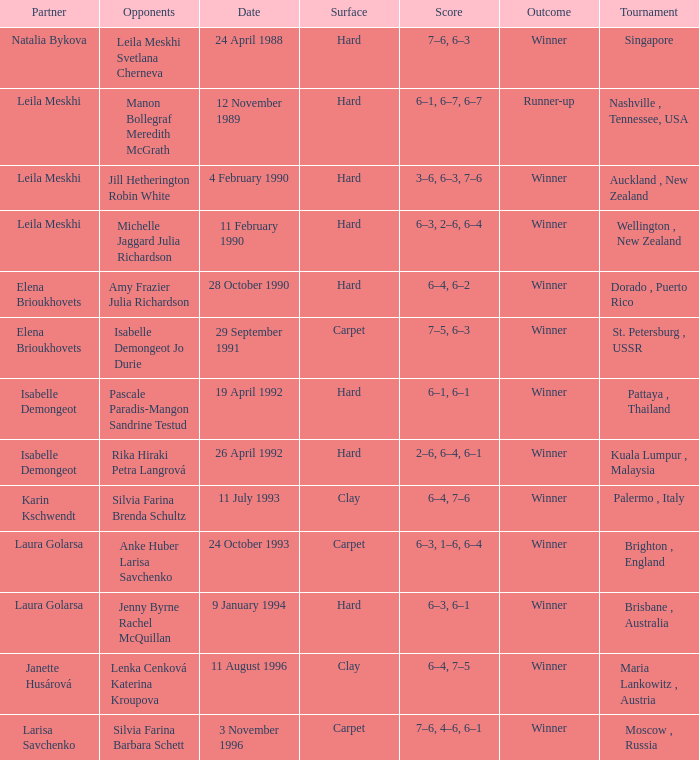Who was the Partner in a game with the Score of 6–4, 6–2 on a hard surface? Elena Brioukhovets. 